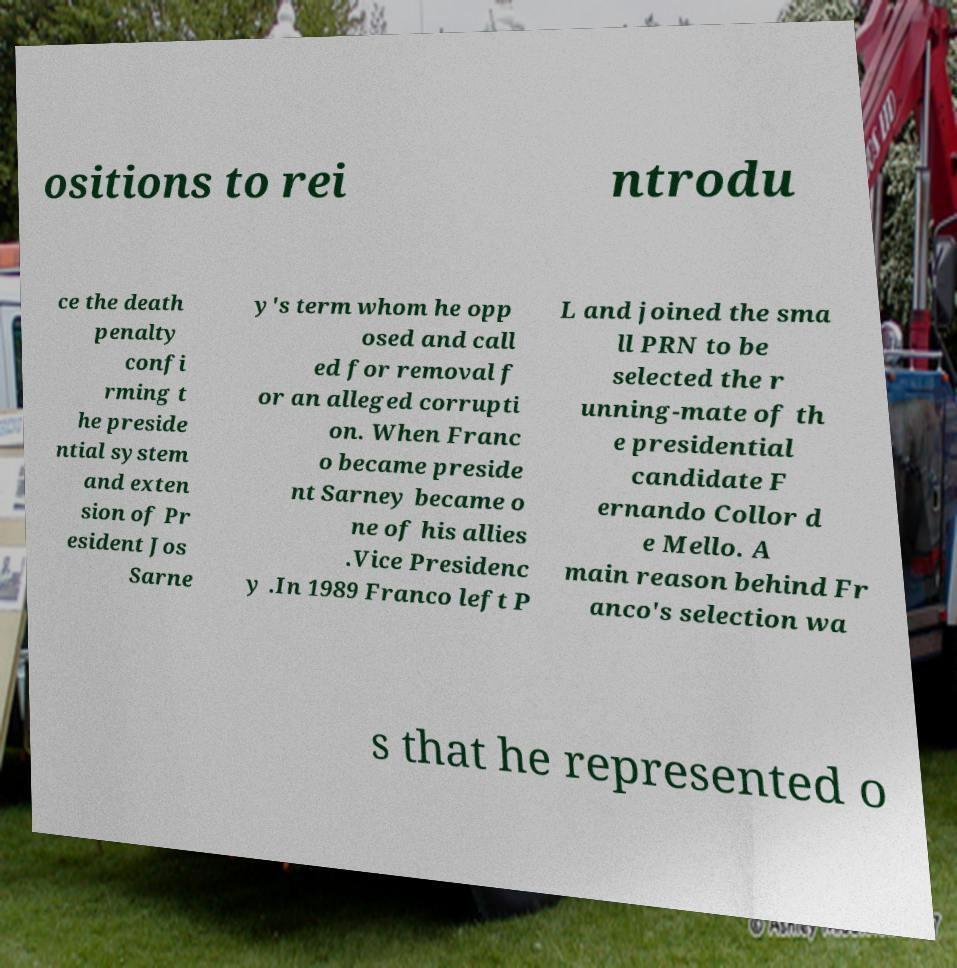There's text embedded in this image that I need extracted. Can you transcribe it verbatim? ositions to rei ntrodu ce the death penalty confi rming t he preside ntial system and exten sion of Pr esident Jos Sarne y's term whom he opp osed and call ed for removal f or an alleged corrupti on. When Franc o became preside nt Sarney became o ne of his allies .Vice Presidenc y .In 1989 Franco left P L and joined the sma ll PRN to be selected the r unning-mate of th e presidential candidate F ernando Collor d e Mello. A main reason behind Fr anco's selection wa s that he represented o 